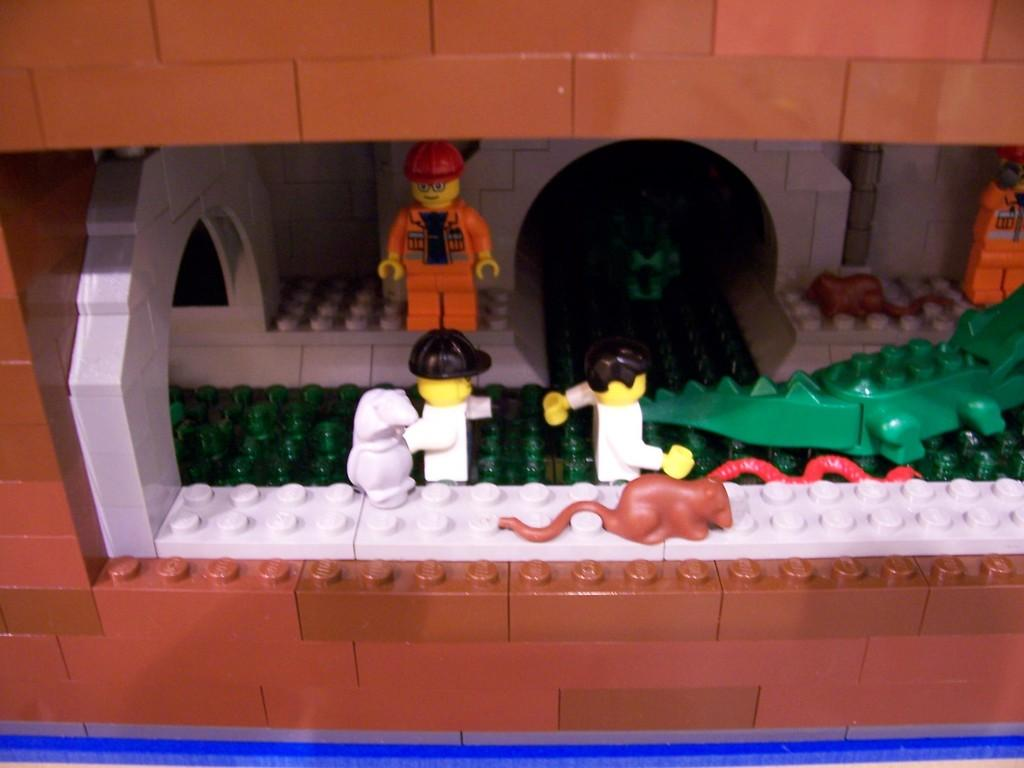What types of toys are present in the image? There are toys of humans and animals in the image. Can you describe the toys of humans in the image? The toys of humans in the image are not specified, but they are present. Can you describe the toys of animals in the image? The toys of animals in the image are not specified, but they are present. Can you see any frogs in the image? There is no mention of frogs in the image, so we cannot confirm their presence. What level of respect do the toys have for each other in the image? The level of respect between the toys is not mentioned in the image, as it is not a relevant aspect of the image. 